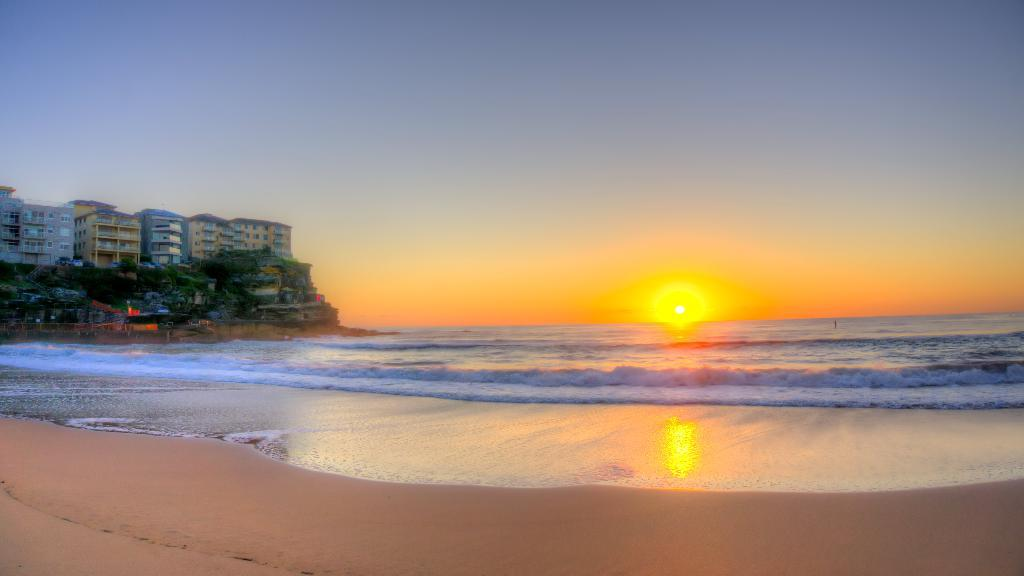What is the main celestial body in the center of the image? The sun is in the center of the image. What type of natural feature is visible in the image? There is a sea in the image. What can be seen at the bottom of the image? A seashore is visible at the bottom of the image. Where are the buildings and trees located in the image? They are on the left side of the image. What else is visible in the image besides the sea and the sun? The sky is visible in the image. What type of furniture can be seen floating in the ocean in the image? There is no furniture visible in the image, and the sea is not referred to as an ocean in the provided facts. 